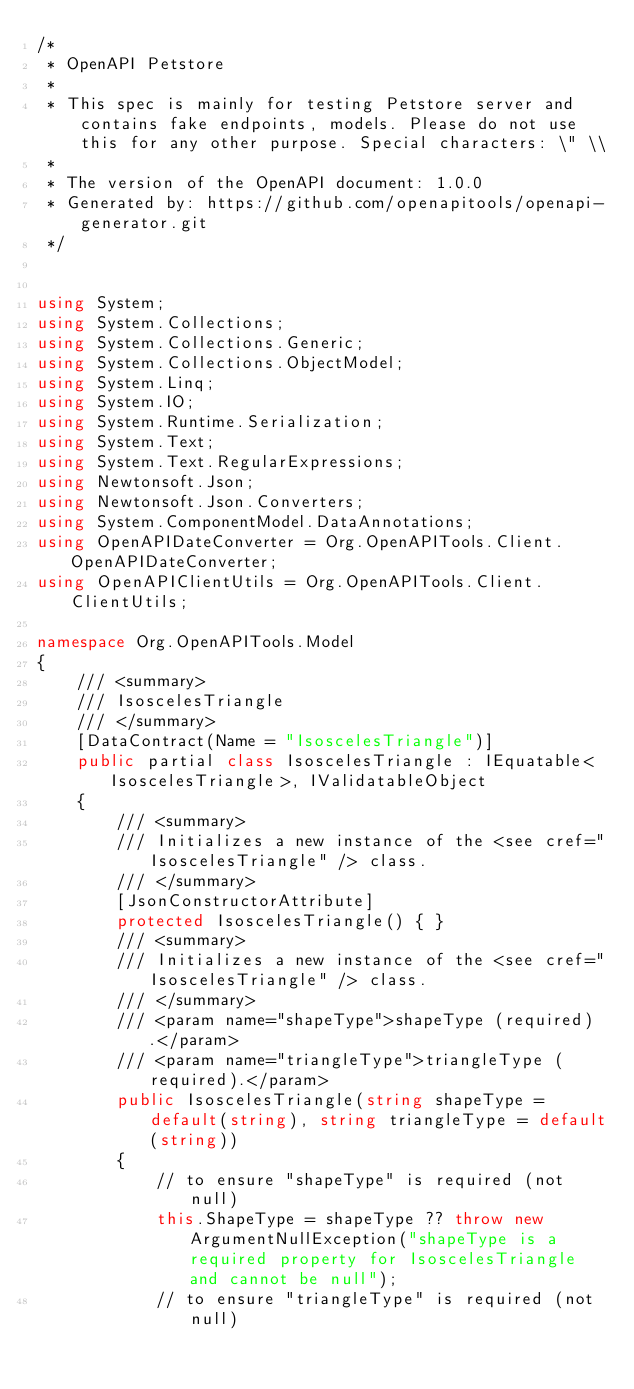<code> <loc_0><loc_0><loc_500><loc_500><_C#_>/*
 * OpenAPI Petstore
 *
 * This spec is mainly for testing Petstore server and contains fake endpoints, models. Please do not use this for any other purpose. Special characters: \" \\
 *
 * The version of the OpenAPI document: 1.0.0
 * Generated by: https://github.com/openapitools/openapi-generator.git
 */


using System;
using System.Collections;
using System.Collections.Generic;
using System.Collections.ObjectModel;
using System.Linq;
using System.IO;
using System.Runtime.Serialization;
using System.Text;
using System.Text.RegularExpressions;
using Newtonsoft.Json;
using Newtonsoft.Json.Converters;
using System.ComponentModel.DataAnnotations;
using OpenAPIDateConverter = Org.OpenAPITools.Client.OpenAPIDateConverter;
using OpenAPIClientUtils = Org.OpenAPITools.Client.ClientUtils;

namespace Org.OpenAPITools.Model
{
    /// <summary>
    /// IsoscelesTriangle
    /// </summary>
    [DataContract(Name = "IsoscelesTriangle")]
    public partial class IsoscelesTriangle : IEquatable<IsoscelesTriangle>, IValidatableObject
    {
        /// <summary>
        /// Initializes a new instance of the <see cref="IsoscelesTriangle" /> class.
        /// </summary>
        [JsonConstructorAttribute]
        protected IsoscelesTriangle() { }
        /// <summary>
        /// Initializes a new instance of the <see cref="IsoscelesTriangle" /> class.
        /// </summary>
        /// <param name="shapeType">shapeType (required).</param>
        /// <param name="triangleType">triangleType (required).</param>
        public IsoscelesTriangle(string shapeType = default(string), string triangleType = default(string))
        {
            // to ensure "shapeType" is required (not null)
            this.ShapeType = shapeType ?? throw new ArgumentNullException("shapeType is a required property for IsoscelesTriangle and cannot be null");
            // to ensure "triangleType" is required (not null)</code> 